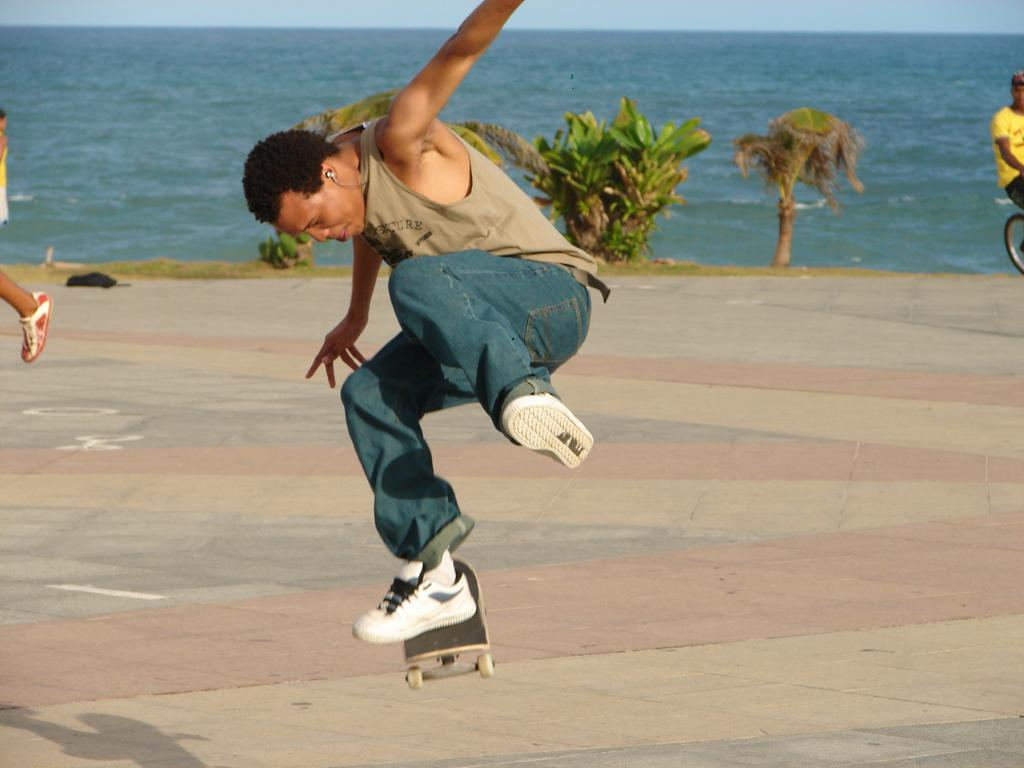What is the main subject of the image? There is a person performing a stunt on a skateboard in the center of the image. What can be seen in the background of the image? There are plants, persons, and an ocean visible in the background of the image. What type of yam is being used as a border in the image? There is no yam present in the image, nor is there any indication of a border. 